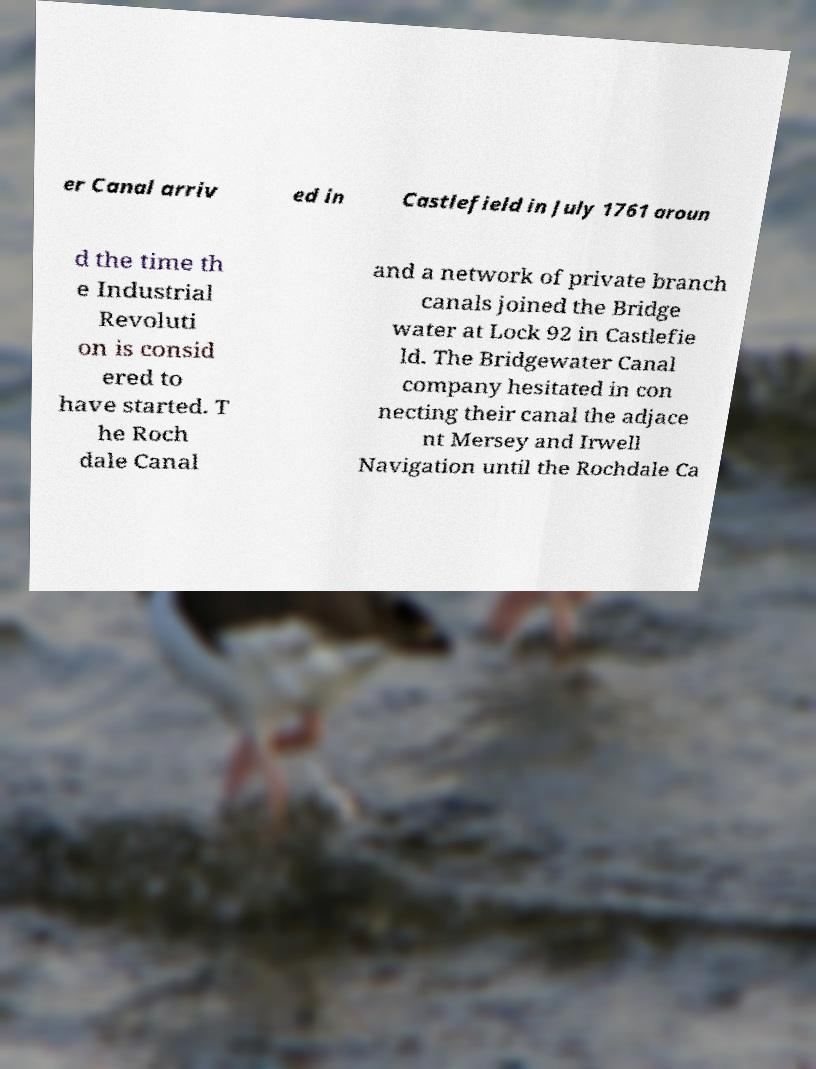Could you assist in decoding the text presented in this image and type it out clearly? er Canal arriv ed in Castlefield in July 1761 aroun d the time th e Industrial Revoluti on is consid ered to have started. T he Roch dale Canal and a network of private branch canals joined the Bridge water at Lock 92 in Castlefie ld. The Bridgewater Canal company hesitated in con necting their canal the adjace nt Mersey and Irwell Navigation until the Rochdale Ca 